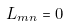<formula> <loc_0><loc_0><loc_500><loc_500>L _ { m n } = 0</formula> 